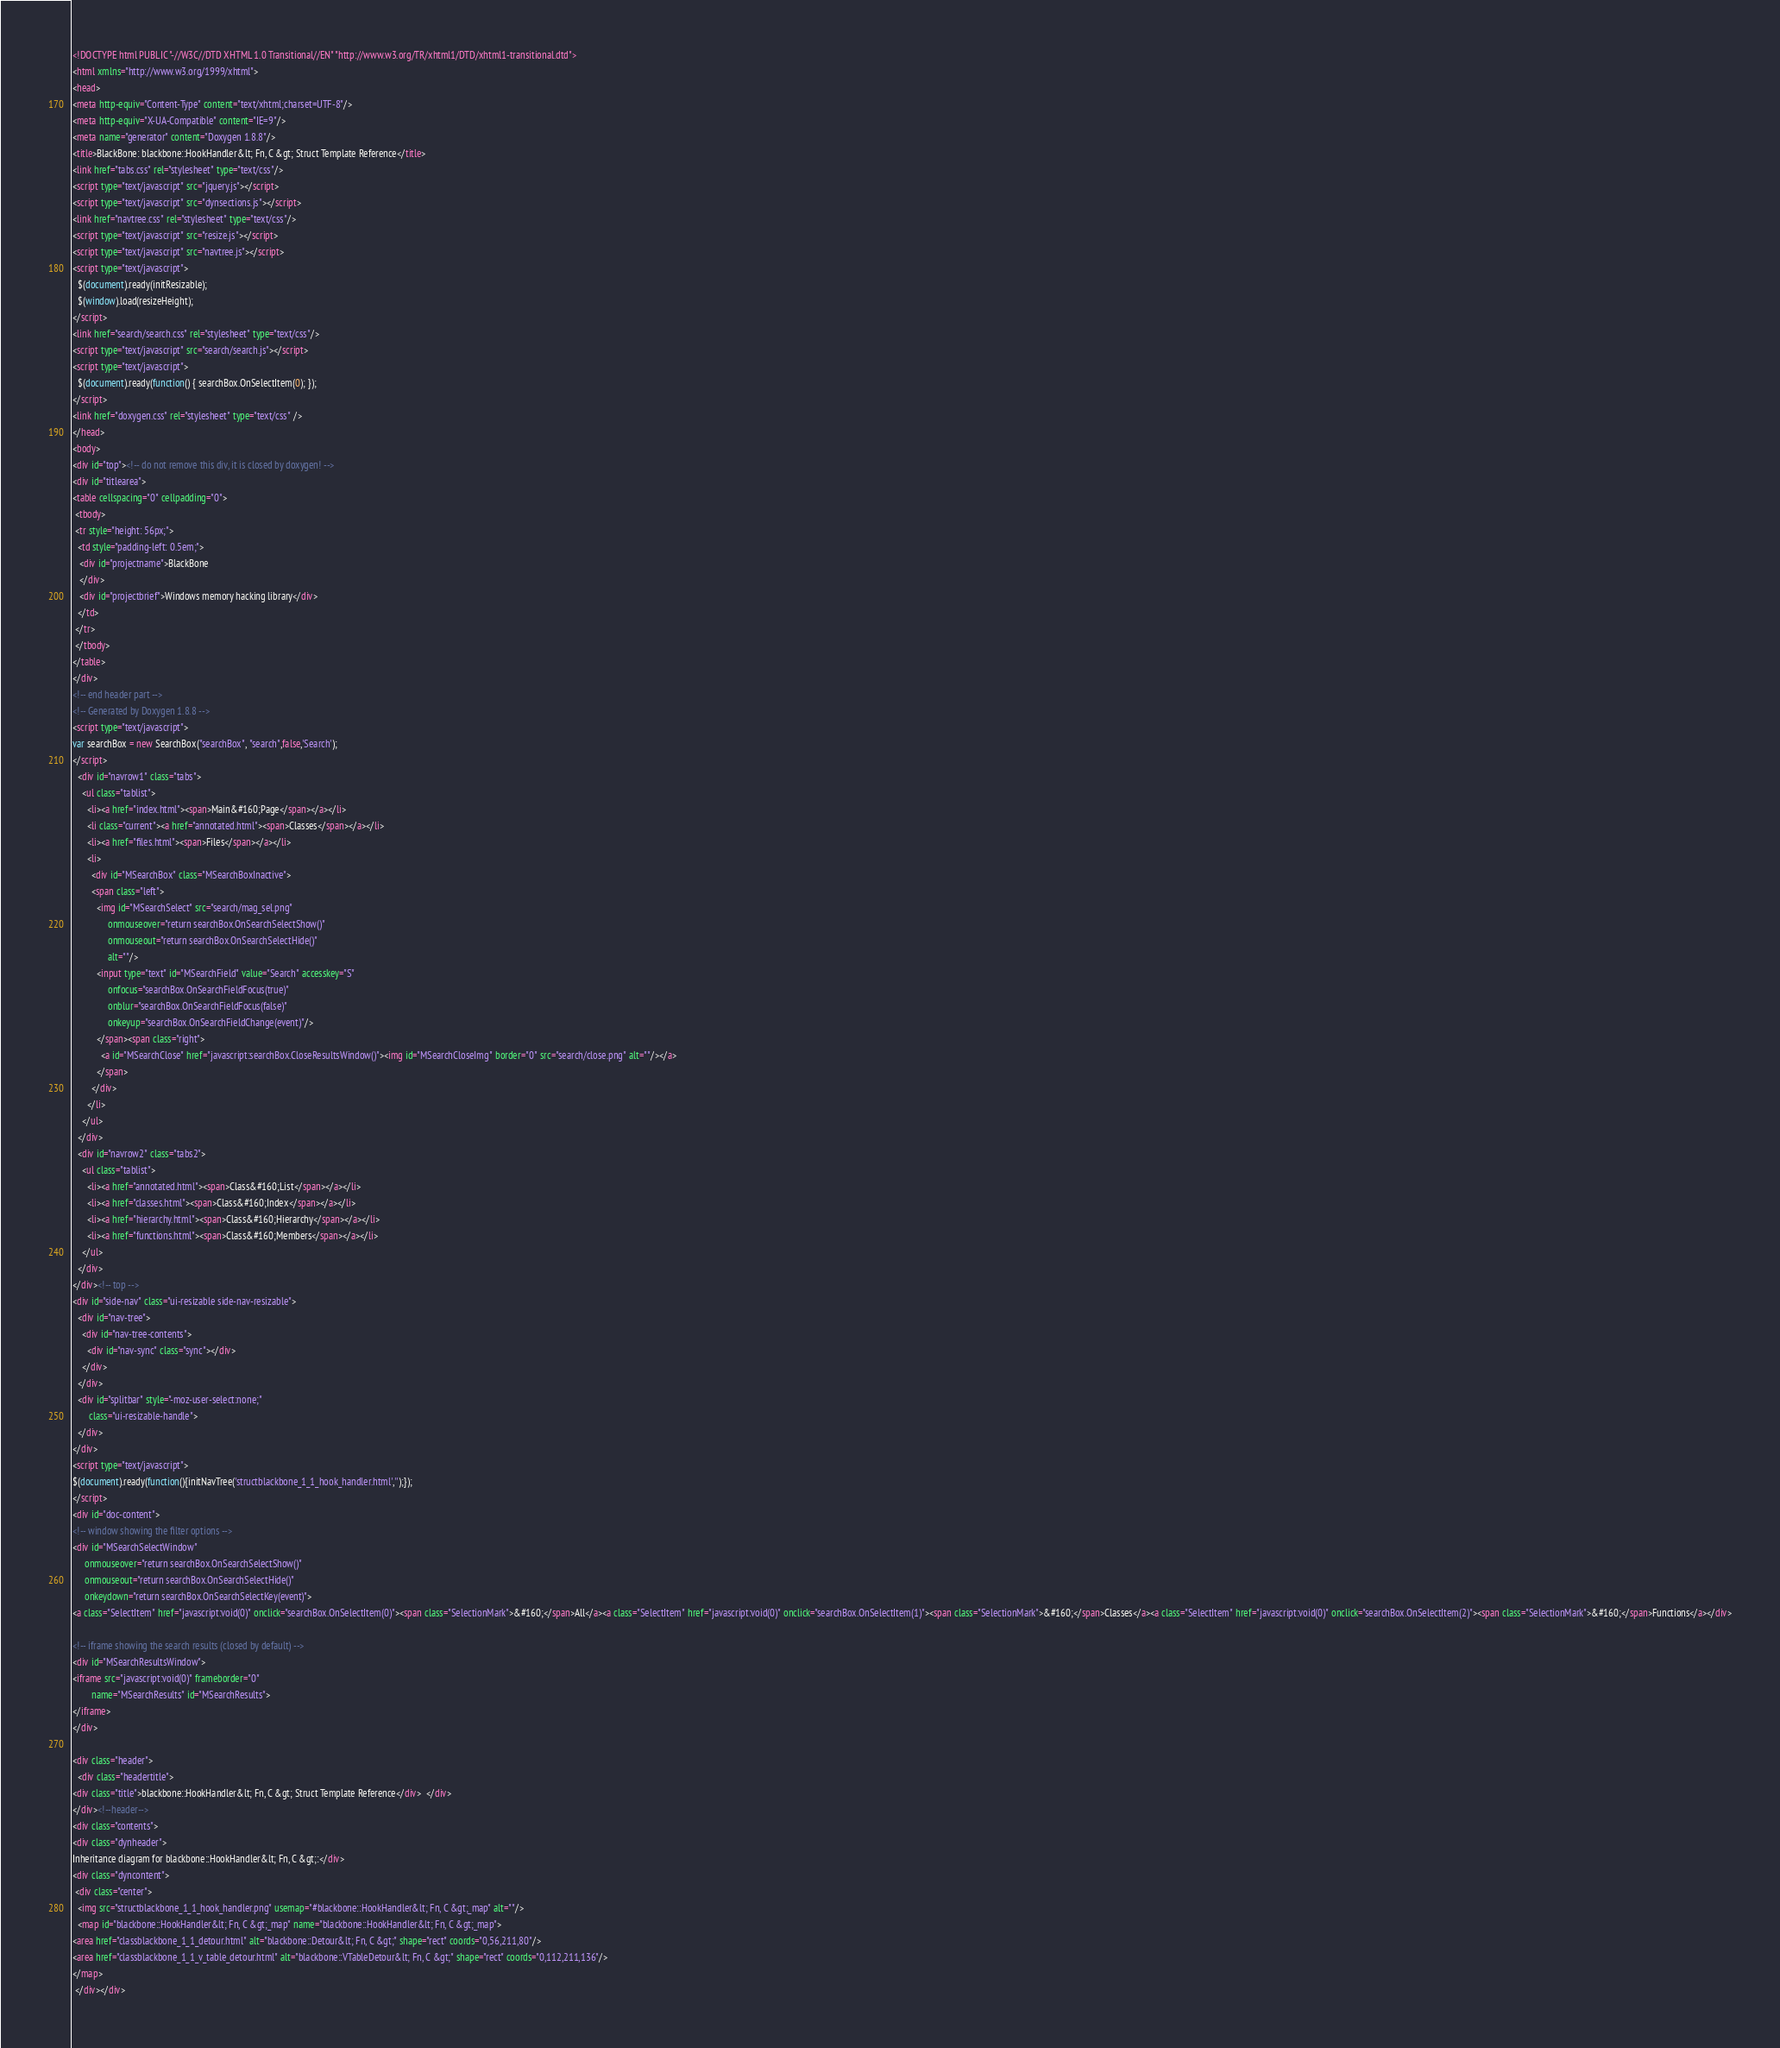<code> <loc_0><loc_0><loc_500><loc_500><_HTML_><!DOCTYPE html PUBLIC "-//W3C//DTD XHTML 1.0 Transitional//EN" "http://www.w3.org/TR/xhtml1/DTD/xhtml1-transitional.dtd">
<html xmlns="http://www.w3.org/1999/xhtml">
<head>
<meta http-equiv="Content-Type" content="text/xhtml;charset=UTF-8"/>
<meta http-equiv="X-UA-Compatible" content="IE=9"/>
<meta name="generator" content="Doxygen 1.8.8"/>
<title>BlackBone: blackbone::HookHandler&lt; Fn, C &gt; Struct Template Reference</title>
<link href="tabs.css" rel="stylesheet" type="text/css"/>
<script type="text/javascript" src="jquery.js"></script>
<script type="text/javascript" src="dynsections.js"></script>
<link href="navtree.css" rel="stylesheet" type="text/css"/>
<script type="text/javascript" src="resize.js"></script>
<script type="text/javascript" src="navtree.js"></script>
<script type="text/javascript">
  $(document).ready(initResizable);
  $(window).load(resizeHeight);
</script>
<link href="search/search.css" rel="stylesheet" type="text/css"/>
<script type="text/javascript" src="search/search.js"></script>
<script type="text/javascript">
  $(document).ready(function() { searchBox.OnSelectItem(0); });
</script>
<link href="doxygen.css" rel="stylesheet" type="text/css" />
</head>
<body>
<div id="top"><!-- do not remove this div, it is closed by doxygen! -->
<div id="titlearea">
<table cellspacing="0" cellpadding="0">
 <tbody>
 <tr style="height: 56px;">
  <td style="padding-left: 0.5em;">
   <div id="projectname">BlackBone
   </div>
   <div id="projectbrief">Windows memory hacking library</div>
  </td>
 </tr>
 </tbody>
</table>
</div>
<!-- end header part -->
<!-- Generated by Doxygen 1.8.8 -->
<script type="text/javascript">
var searchBox = new SearchBox("searchBox", "search",false,'Search');
</script>
  <div id="navrow1" class="tabs">
    <ul class="tablist">
      <li><a href="index.html"><span>Main&#160;Page</span></a></li>
      <li class="current"><a href="annotated.html"><span>Classes</span></a></li>
      <li><a href="files.html"><span>Files</span></a></li>
      <li>
        <div id="MSearchBox" class="MSearchBoxInactive">
        <span class="left">
          <img id="MSearchSelect" src="search/mag_sel.png"
               onmouseover="return searchBox.OnSearchSelectShow()"
               onmouseout="return searchBox.OnSearchSelectHide()"
               alt=""/>
          <input type="text" id="MSearchField" value="Search" accesskey="S"
               onfocus="searchBox.OnSearchFieldFocus(true)" 
               onblur="searchBox.OnSearchFieldFocus(false)" 
               onkeyup="searchBox.OnSearchFieldChange(event)"/>
          </span><span class="right">
            <a id="MSearchClose" href="javascript:searchBox.CloseResultsWindow()"><img id="MSearchCloseImg" border="0" src="search/close.png" alt=""/></a>
          </span>
        </div>
      </li>
    </ul>
  </div>
  <div id="navrow2" class="tabs2">
    <ul class="tablist">
      <li><a href="annotated.html"><span>Class&#160;List</span></a></li>
      <li><a href="classes.html"><span>Class&#160;Index</span></a></li>
      <li><a href="hierarchy.html"><span>Class&#160;Hierarchy</span></a></li>
      <li><a href="functions.html"><span>Class&#160;Members</span></a></li>
    </ul>
  </div>
</div><!-- top -->
<div id="side-nav" class="ui-resizable side-nav-resizable">
  <div id="nav-tree">
    <div id="nav-tree-contents">
      <div id="nav-sync" class="sync"></div>
    </div>
  </div>
  <div id="splitbar" style="-moz-user-select:none;" 
       class="ui-resizable-handle">
  </div>
</div>
<script type="text/javascript">
$(document).ready(function(){initNavTree('structblackbone_1_1_hook_handler.html','');});
</script>
<div id="doc-content">
<!-- window showing the filter options -->
<div id="MSearchSelectWindow"
     onmouseover="return searchBox.OnSearchSelectShow()"
     onmouseout="return searchBox.OnSearchSelectHide()"
     onkeydown="return searchBox.OnSearchSelectKey(event)">
<a class="SelectItem" href="javascript:void(0)" onclick="searchBox.OnSelectItem(0)"><span class="SelectionMark">&#160;</span>All</a><a class="SelectItem" href="javascript:void(0)" onclick="searchBox.OnSelectItem(1)"><span class="SelectionMark">&#160;</span>Classes</a><a class="SelectItem" href="javascript:void(0)" onclick="searchBox.OnSelectItem(2)"><span class="SelectionMark">&#160;</span>Functions</a></div>

<!-- iframe showing the search results (closed by default) -->
<div id="MSearchResultsWindow">
<iframe src="javascript:void(0)" frameborder="0" 
        name="MSearchResults" id="MSearchResults">
</iframe>
</div>

<div class="header">
  <div class="headertitle">
<div class="title">blackbone::HookHandler&lt; Fn, C &gt; Struct Template Reference</div>  </div>
</div><!--header-->
<div class="contents">
<div class="dynheader">
Inheritance diagram for blackbone::HookHandler&lt; Fn, C &gt;:</div>
<div class="dyncontent">
 <div class="center">
  <img src="structblackbone_1_1_hook_handler.png" usemap="#blackbone::HookHandler&lt; Fn, C &gt;_map" alt=""/>
  <map id="blackbone::HookHandler&lt; Fn, C &gt;_map" name="blackbone::HookHandler&lt; Fn, C &gt;_map">
<area href="classblackbone_1_1_detour.html" alt="blackbone::Detour&lt; Fn, C &gt;" shape="rect" coords="0,56,211,80"/>
<area href="classblackbone_1_1_v_table_detour.html" alt="blackbone::VTableDetour&lt; Fn, C &gt;" shape="rect" coords="0,112,211,136"/>
</map>
 </div></div></code> 